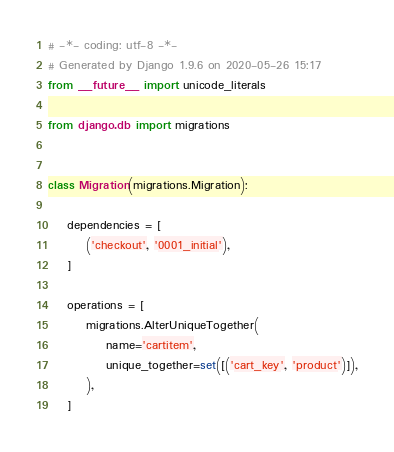Convert code to text. <code><loc_0><loc_0><loc_500><loc_500><_Python_># -*- coding: utf-8 -*-
# Generated by Django 1.9.6 on 2020-05-26 15:17
from __future__ import unicode_literals

from django.db import migrations


class Migration(migrations.Migration):

    dependencies = [
        ('checkout', '0001_initial'),
    ]

    operations = [
        migrations.AlterUniqueTogether(
            name='cartitem',
            unique_together=set([('cart_key', 'product')]),
        ),
    ]
</code> 